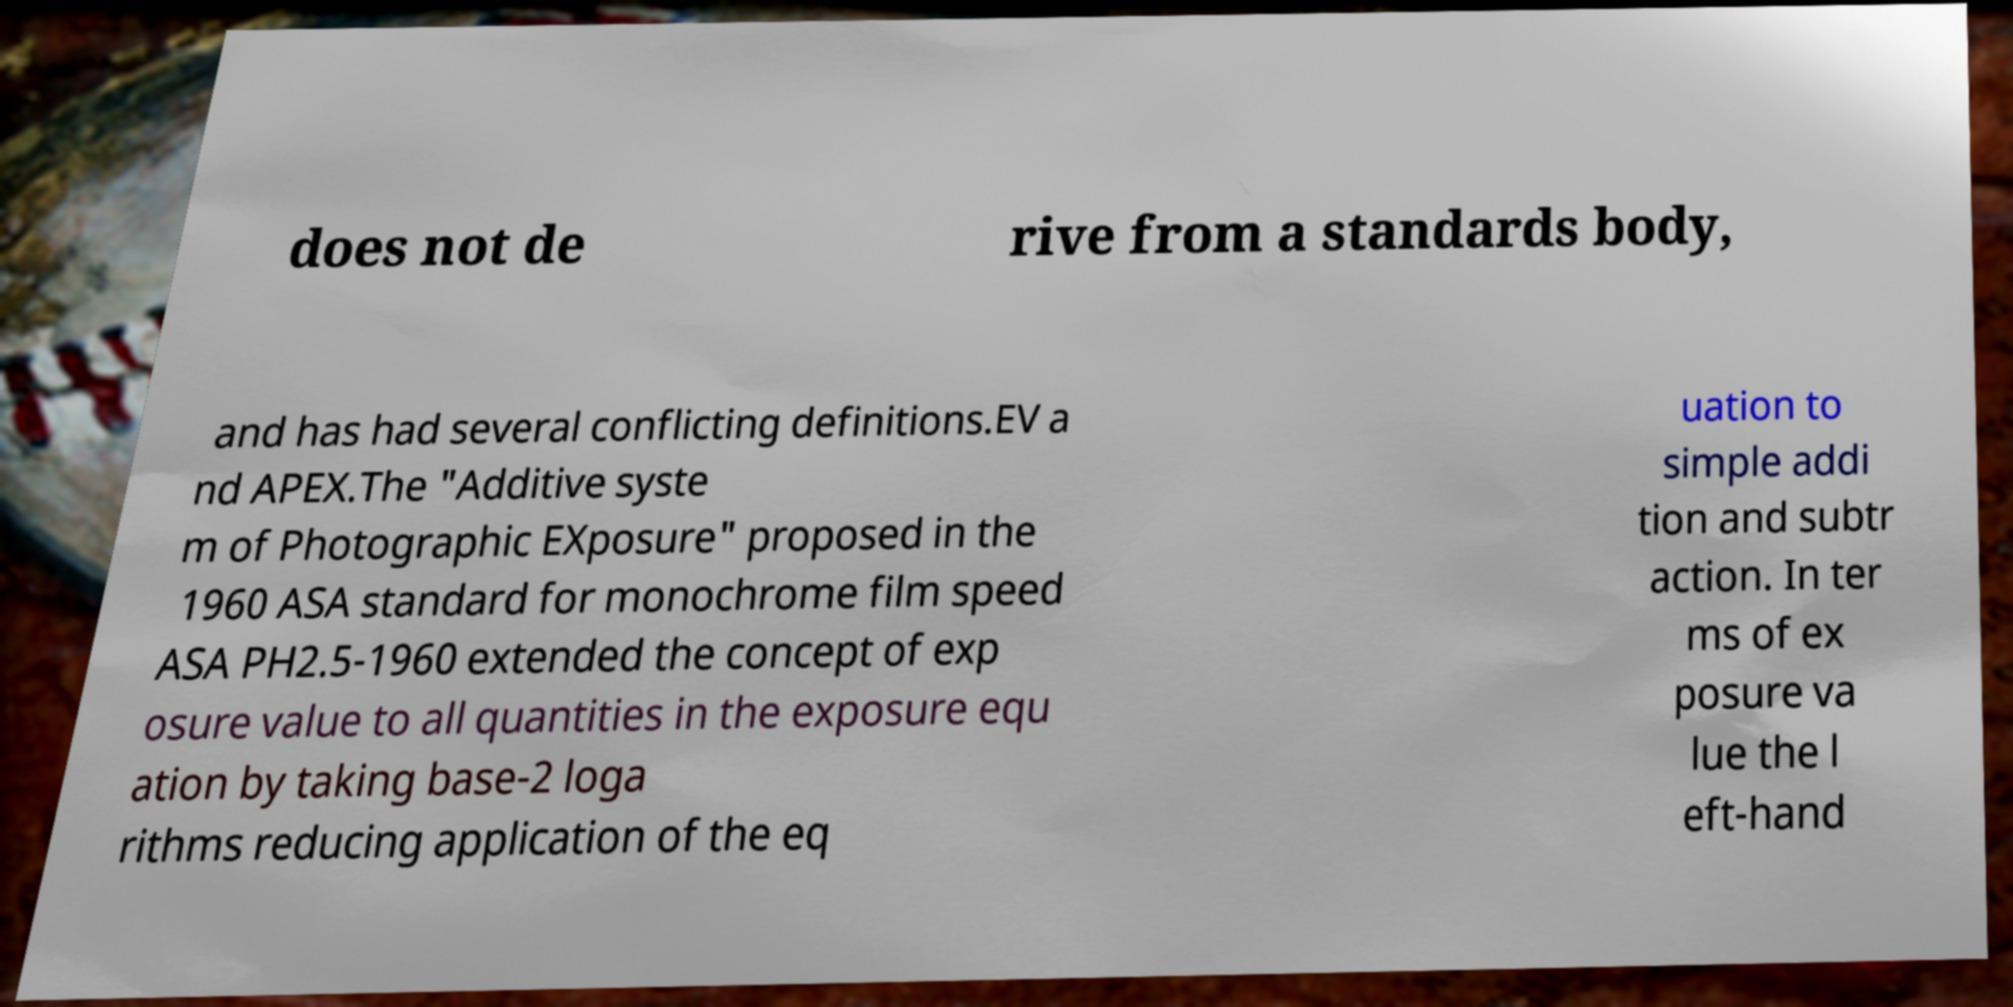I need the written content from this picture converted into text. Can you do that? does not de rive from a standards body, and has had several conflicting definitions.EV a nd APEX.The "Additive syste m of Photographic EXposure" proposed in the 1960 ASA standard for monochrome film speed ASA PH2.5-1960 extended the concept of exp osure value to all quantities in the exposure equ ation by taking base-2 loga rithms reducing application of the eq uation to simple addi tion and subtr action. In ter ms of ex posure va lue the l eft-hand 